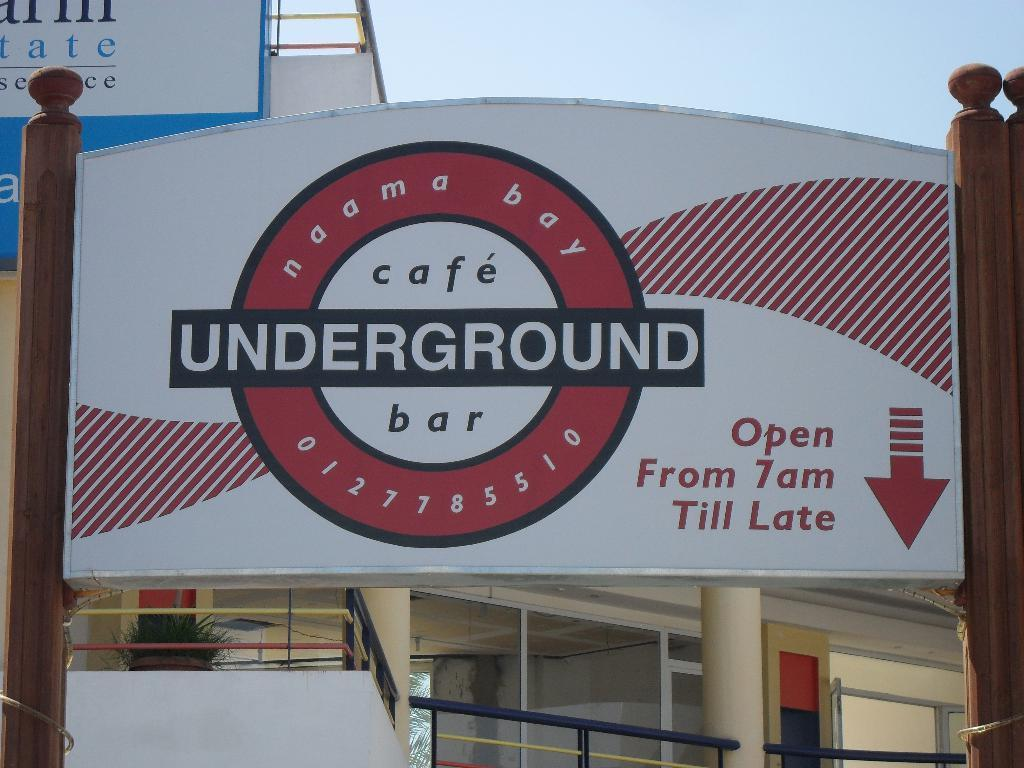What is the main structure in the image? There are wooden poles with a board in the image. What can be seen in the background of the image? There is a building, another board, pillars, and the sky visible in the background of the image. Can you tell me how many people are stuck in the quicksand in the image? There is no quicksand present in the image, so it is not possible to determine how many people might be stuck in it. 